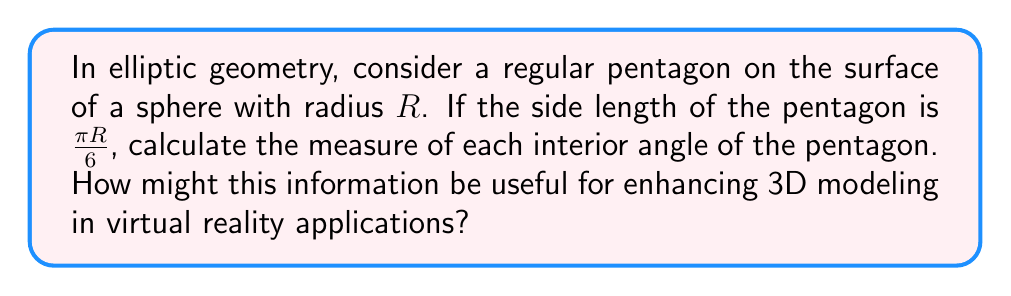Help me with this question. Let's approach this step-by-step:

1) In elliptic geometry, the sum of the angles in a pentagon is greater than $540°$ (the Euclidean sum). The excess is given by the area of the pentagon.

2) For a regular pentagon, all sides and angles are equal. Let's denote each angle as $\theta$.

3) The area of a regular polygon on a sphere is given by:

   $$A = (\text{number of sides} - 2)\pi - \text{sum of exterior angles}$$

4) In our case, the number of sides is 5, and the sum of exterior angles is $5(2\pi - \theta)$.

5) Thus, the area $A$ is:

   $$A = (5-2)\pi - 5(2\pi - \theta) = 3\pi - 10\pi + 5\theta = 5\theta - 7\pi$$

6) The area of a spherical pentagon can also be calculated using the side length $a$:

   $$A = 5\arccos\left(\frac{\cos(\frac{a}{R})+\cos^2(\frac{\pi}{5})}{\sin^2(\frac{\pi}{5})}\right) - 3\pi$$

7) Given $a = \frac{\pi R}{6}$, we can substitute this into the equation:

   $$5\theta - 7\pi = 5\arccos\left(\frac{\cos(\frac{\pi}{6})+\cos^2(\frac{\pi}{5})}{\sin^2(\frac{\pi}{5})}\right) - 3\pi$$

8) Solving for $\theta$:

   $$\theta = \arccos\left(\frac{\cos(\frac{\pi}{6})+\cos^2(\frac{\pi}{5})}{\sin^2(\frac{\pi}{5})}\right) + \frac{4\pi}{5}$$

9) Calculating this:

   $$\theta \approx 2.670 \text{ radians} \approx 153.0°$$

This result is useful for enhancing 3D modeling in virtual reality applications as it allows for accurate representation of non-Euclidean shapes. In VR, objects might need to be rendered on curved surfaces or in spaces with different geometries, and understanding how shapes behave in these spaces is crucial for creating immersive and realistic environments.
Answer: $153.0°$ 